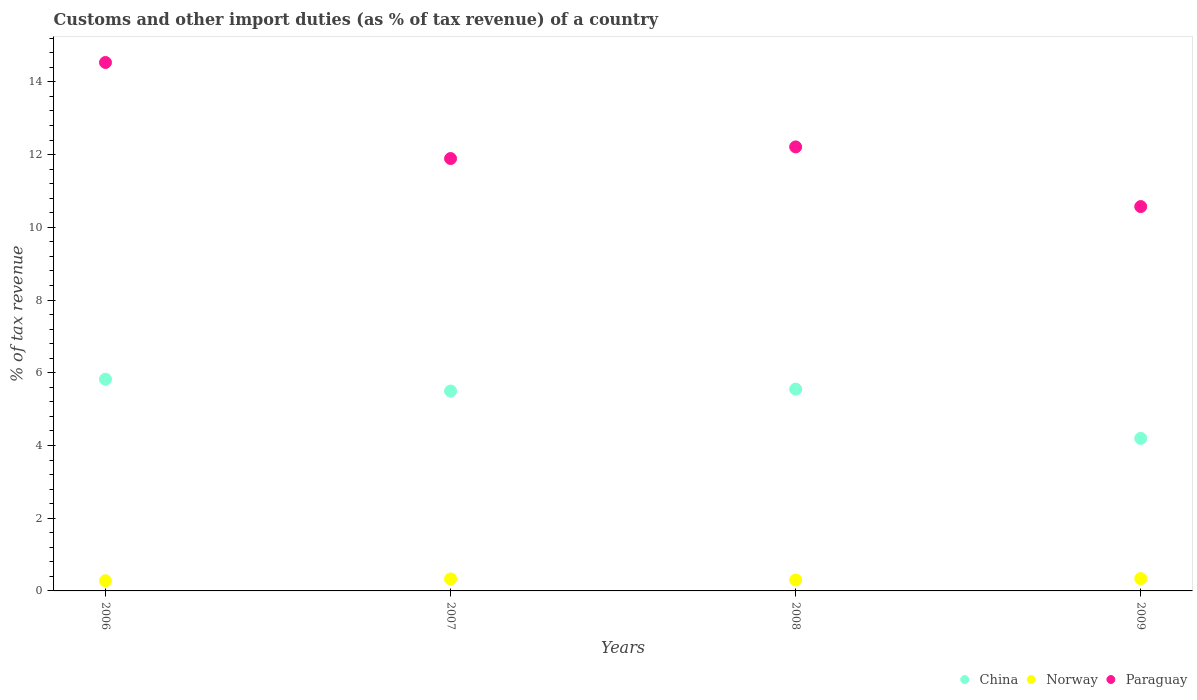What is the percentage of tax revenue from customs in China in 2006?
Provide a short and direct response. 5.82. Across all years, what is the maximum percentage of tax revenue from customs in Norway?
Your answer should be very brief. 0.34. Across all years, what is the minimum percentage of tax revenue from customs in Paraguay?
Your answer should be compact. 10.57. In which year was the percentage of tax revenue from customs in Norway minimum?
Offer a very short reply. 2006. What is the total percentage of tax revenue from customs in China in the graph?
Give a very brief answer. 21.07. What is the difference between the percentage of tax revenue from customs in Paraguay in 2007 and that in 2008?
Your answer should be very brief. -0.32. What is the difference between the percentage of tax revenue from customs in China in 2006 and the percentage of tax revenue from customs in Norway in 2007?
Your answer should be very brief. 5.5. What is the average percentage of tax revenue from customs in China per year?
Ensure brevity in your answer.  5.27. In the year 2007, what is the difference between the percentage of tax revenue from customs in Norway and percentage of tax revenue from customs in Paraguay?
Keep it short and to the point. -11.56. What is the ratio of the percentage of tax revenue from customs in China in 2007 to that in 2009?
Your response must be concise. 1.31. Is the percentage of tax revenue from customs in China in 2006 less than that in 2009?
Provide a succinct answer. No. Is the difference between the percentage of tax revenue from customs in Norway in 2007 and 2008 greater than the difference between the percentage of tax revenue from customs in Paraguay in 2007 and 2008?
Your answer should be compact. Yes. What is the difference between the highest and the second highest percentage of tax revenue from customs in Paraguay?
Make the answer very short. 2.32. What is the difference between the highest and the lowest percentage of tax revenue from customs in China?
Your answer should be compact. 1.63. In how many years, is the percentage of tax revenue from customs in China greater than the average percentage of tax revenue from customs in China taken over all years?
Keep it short and to the point. 3. Is the sum of the percentage of tax revenue from customs in China in 2008 and 2009 greater than the maximum percentage of tax revenue from customs in Norway across all years?
Provide a succinct answer. Yes. Is it the case that in every year, the sum of the percentage of tax revenue from customs in Norway and percentage of tax revenue from customs in China  is greater than the percentage of tax revenue from customs in Paraguay?
Provide a short and direct response. No. Is the percentage of tax revenue from customs in Norway strictly less than the percentage of tax revenue from customs in Paraguay over the years?
Provide a short and direct response. Yes. How many years are there in the graph?
Keep it short and to the point. 4. Are the values on the major ticks of Y-axis written in scientific E-notation?
Keep it short and to the point. No. Does the graph contain grids?
Offer a very short reply. No. Where does the legend appear in the graph?
Your answer should be compact. Bottom right. How many legend labels are there?
Give a very brief answer. 3. What is the title of the graph?
Keep it short and to the point. Customs and other import duties (as % of tax revenue) of a country. Does "Bolivia" appear as one of the legend labels in the graph?
Your answer should be compact. No. What is the label or title of the X-axis?
Make the answer very short. Years. What is the label or title of the Y-axis?
Provide a succinct answer. % of tax revenue. What is the % of tax revenue in China in 2006?
Provide a succinct answer. 5.82. What is the % of tax revenue in Norway in 2006?
Keep it short and to the point. 0.28. What is the % of tax revenue in Paraguay in 2006?
Give a very brief answer. 14.53. What is the % of tax revenue in China in 2007?
Provide a succinct answer. 5.5. What is the % of tax revenue in Norway in 2007?
Offer a terse response. 0.33. What is the % of tax revenue in Paraguay in 2007?
Keep it short and to the point. 11.89. What is the % of tax revenue of China in 2008?
Your answer should be very brief. 5.55. What is the % of tax revenue in Norway in 2008?
Provide a succinct answer. 0.3. What is the % of tax revenue of Paraguay in 2008?
Give a very brief answer. 12.21. What is the % of tax revenue in China in 2009?
Your answer should be compact. 4.2. What is the % of tax revenue of Norway in 2009?
Provide a succinct answer. 0.34. What is the % of tax revenue of Paraguay in 2009?
Offer a very short reply. 10.57. Across all years, what is the maximum % of tax revenue in China?
Ensure brevity in your answer.  5.82. Across all years, what is the maximum % of tax revenue in Norway?
Keep it short and to the point. 0.34. Across all years, what is the maximum % of tax revenue of Paraguay?
Your answer should be very brief. 14.53. Across all years, what is the minimum % of tax revenue in China?
Give a very brief answer. 4.2. Across all years, what is the minimum % of tax revenue of Norway?
Make the answer very short. 0.28. Across all years, what is the minimum % of tax revenue of Paraguay?
Keep it short and to the point. 10.57. What is the total % of tax revenue in China in the graph?
Provide a short and direct response. 21.07. What is the total % of tax revenue of Norway in the graph?
Provide a short and direct response. 1.25. What is the total % of tax revenue of Paraguay in the graph?
Ensure brevity in your answer.  49.21. What is the difference between the % of tax revenue of China in 2006 and that in 2007?
Ensure brevity in your answer.  0.33. What is the difference between the % of tax revenue in Norway in 2006 and that in 2007?
Keep it short and to the point. -0.05. What is the difference between the % of tax revenue of Paraguay in 2006 and that in 2007?
Make the answer very short. 2.64. What is the difference between the % of tax revenue in China in 2006 and that in 2008?
Offer a very short reply. 0.27. What is the difference between the % of tax revenue in Norway in 2006 and that in 2008?
Offer a very short reply. -0.02. What is the difference between the % of tax revenue in Paraguay in 2006 and that in 2008?
Provide a short and direct response. 2.32. What is the difference between the % of tax revenue in China in 2006 and that in 2009?
Your answer should be very brief. 1.63. What is the difference between the % of tax revenue in Norway in 2006 and that in 2009?
Offer a terse response. -0.06. What is the difference between the % of tax revenue of Paraguay in 2006 and that in 2009?
Your answer should be compact. 3.96. What is the difference between the % of tax revenue in China in 2007 and that in 2008?
Provide a short and direct response. -0.05. What is the difference between the % of tax revenue of Norway in 2007 and that in 2008?
Offer a terse response. 0.03. What is the difference between the % of tax revenue in Paraguay in 2007 and that in 2008?
Offer a terse response. -0.32. What is the difference between the % of tax revenue in China in 2007 and that in 2009?
Ensure brevity in your answer.  1.3. What is the difference between the % of tax revenue in Norway in 2007 and that in 2009?
Provide a short and direct response. -0.01. What is the difference between the % of tax revenue in Paraguay in 2007 and that in 2009?
Ensure brevity in your answer.  1.32. What is the difference between the % of tax revenue in China in 2008 and that in 2009?
Make the answer very short. 1.36. What is the difference between the % of tax revenue of Norway in 2008 and that in 2009?
Your answer should be compact. -0.04. What is the difference between the % of tax revenue in Paraguay in 2008 and that in 2009?
Offer a very short reply. 1.64. What is the difference between the % of tax revenue of China in 2006 and the % of tax revenue of Norway in 2007?
Your response must be concise. 5.5. What is the difference between the % of tax revenue in China in 2006 and the % of tax revenue in Paraguay in 2007?
Give a very brief answer. -6.07. What is the difference between the % of tax revenue in Norway in 2006 and the % of tax revenue in Paraguay in 2007?
Give a very brief answer. -11.61. What is the difference between the % of tax revenue in China in 2006 and the % of tax revenue in Norway in 2008?
Offer a very short reply. 5.52. What is the difference between the % of tax revenue of China in 2006 and the % of tax revenue of Paraguay in 2008?
Make the answer very short. -6.39. What is the difference between the % of tax revenue in Norway in 2006 and the % of tax revenue in Paraguay in 2008?
Your answer should be very brief. -11.93. What is the difference between the % of tax revenue of China in 2006 and the % of tax revenue of Norway in 2009?
Your answer should be compact. 5.49. What is the difference between the % of tax revenue in China in 2006 and the % of tax revenue in Paraguay in 2009?
Your response must be concise. -4.75. What is the difference between the % of tax revenue in Norway in 2006 and the % of tax revenue in Paraguay in 2009?
Keep it short and to the point. -10.29. What is the difference between the % of tax revenue in China in 2007 and the % of tax revenue in Norway in 2008?
Offer a very short reply. 5.2. What is the difference between the % of tax revenue of China in 2007 and the % of tax revenue of Paraguay in 2008?
Provide a succinct answer. -6.71. What is the difference between the % of tax revenue of Norway in 2007 and the % of tax revenue of Paraguay in 2008?
Ensure brevity in your answer.  -11.88. What is the difference between the % of tax revenue of China in 2007 and the % of tax revenue of Norway in 2009?
Ensure brevity in your answer.  5.16. What is the difference between the % of tax revenue in China in 2007 and the % of tax revenue in Paraguay in 2009?
Make the answer very short. -5.07. What is the difference between the % of tax revenue in Norway in 2007 and the % of tax revenue in Paraguay in 2009?
Keep it short and to the point. -10.24. What is the difference between the % of tax revenue of China in 2008 and the % of tax revenue of Norway in 2009?
Ensure brevity in your answer.  5.21. What is the difference between the % of tax revenue of China in 2008 and the % of tax revenue of Paraguay in 2009?
Offer a very short reply. -5.02. What is the difference between the % of tax revenue of Norway in 2008 and the % of tax revenue of Paraguay in 2009?
Your answer should be very brief. -10.27. What is the average % of tax revenue of China per year?
Provide a short and direct response. 5.27. What is the average % of tax revenue in Norway per year?
Provide a succinct answer. 0.31. What is the average % of tax revenue of Paraguay per year?
Provide a succinct answer. 12.3. In the year 2006, what is the difference between the % of tax revenue in China and % of tax revenue in Norway?
Your answer should be compact. 5.54. In the year 2006, what is the difference between the % of tax revenue in China and % of tax revenue in Paraguay?
Your answer should be compact. -8.71. In the year 2006, what is the difference between the % of tax revenue of Norway and % of tax revenue of Paraguay?
Your answer should be compact. -14.25. In the year 2007, what is the difference between the % of tax revenue in China and % of tax revenue in Norway?
Give a very brief answer. 5.17. In the year 2007, what is the difference between the % of tax revenue in China and % of tax revenue in Paraguay?
Keep it short and to the point. -6.39. In the year 2007, what is the difference between the % of tax revenue of Norway and % of tax revenue of Paraguay?
Keep it short and to the point. -11.56. In the year 2008, what is the difference between the % of tax revenue in China and % of tax revenue in Norway?
Give a very brief answer. 5.25. In the year 2008, what is the difference between the % of tax revenue of China and % of tax revenue of Paraguay?
Give a very brief answer. -6.66. In the year 2008, what is the difference between the % of tax revenue in Norway and % of tax revenue in Paraguay?
Provide a short and direct response. -11.91. In the year 2009, what is the difference between the % of tax revenue in China and % of tax revenue in Norway?
Your answer should be compact. 3.86. In the year 2009, what is the difference between the % of tax revenue of China and % of tax revenue of Paraguay?
Your response must be concise. -6.38. In the year 2009, what is the difference between the % of tax revenue of Norway and % of tax revenue of Paraguay?
Provide a succinct answer. -10.23. What is the ratio of the % of tax revenue in China in 2006 to that in 2007?
Keep it short and to the point. 1.06. What is the ratio of the % of tax revenue of Norway in 2006 to that in 2007?
Ensure brevity in your answer.  0.85. What is the ratio of the % of tax revenue of Paraguay in 2006 to that in 2007?
Provide a short and direct response. 1.22. What is the ratio of the % of tax revenue of China in 2006 to that in 2008?
Your answer should be very brief. 1.05. What is the ratio of the % of tax revenue of Norway in 2006 to that in 2008?
Offer a very short reply. 0.93. What is the ratio of the % of tax revenue in Paraguay in 2006 to that in 2008?
Your response must be concise. 1.19. What is the ratio of the % of tax revenue of China in 2006 to that in 2009?
Your answer should be very brief. 1.39. What is the ratio of the % of tax revenue of Norway in 2006 to that in 2009?
Keep it short and to the point. 0.82. What is the ratio of the % of tax revenue of Paraguay in 2006 to that in 2009?
Your answer should be compact. 1.37. What is the ratio of the % of tax revenue of China in 2007 to that in 2008?
Your response must be concise. 0.99. What is the ratio of the % of tax revenue in Norway in 2007 to that in 2008?
Offer a terse response. 1.1. What is the ratio of the % of tax revenue of Paraguay in 2007 to that in 2008?
Keep it short and to the point. 0.97. What is the ratio of the % of tax revenue in China in 2007 to that in 2009?
Offer a terse response. 1.31. What is the ratio of the % of tax revenue in Norway in 2007 to that in 2009?
Keep it short and to the point. 0.97. What is the ratio of the % of tax revenue in Paraguay in 2007 to that in 2009?
Offer a very short reply. 1.12. What is the ratio of the % of tax revenue of China in 2008 to that in 2009?
Provide a short and direct response. 1.32. What is the ratio of the % of tax revenue of Norway in 2008 to that in 2009?
Offer a terse response. 0.89. What is the ratio of the % of tax revenue of Paraguay in 2008 to that in 2009?
Offer a terse response. 1.16. What is the difference between the highest and the second highest % of tax revenue of China?
Ensure brevity in your answer.  0.27. What is the difference between the highest and the second highest % of tax revenue in Norway?
Your response must be concise. 0.01. What is the difference between the highest and the second highest % of tax revenue of Paraguay?
Provide a succinct answer. 2.32. What is the difference between the highest and the lowest % of tax revenue in China?
Keep it short and to the point. 1.63. What is the difference between the highest and the lowest % of tax revenue of Norway?
Your response must be concise. 0.06. What is the difference between the highest and the lowest % of tax revenue of Paraguay?
Your answer should be compact. 3.96. 